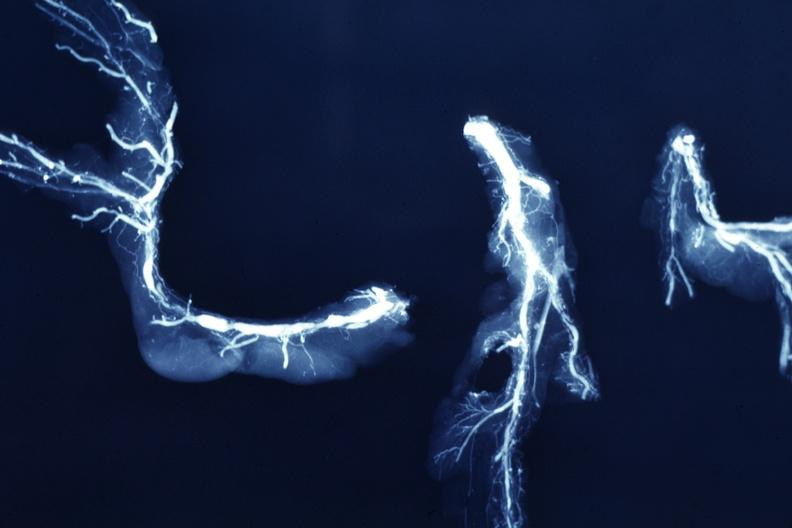does this image show x-ray postmortdissected arteries extensive lesions?
Answer the question using a single word or phrase. Yes 